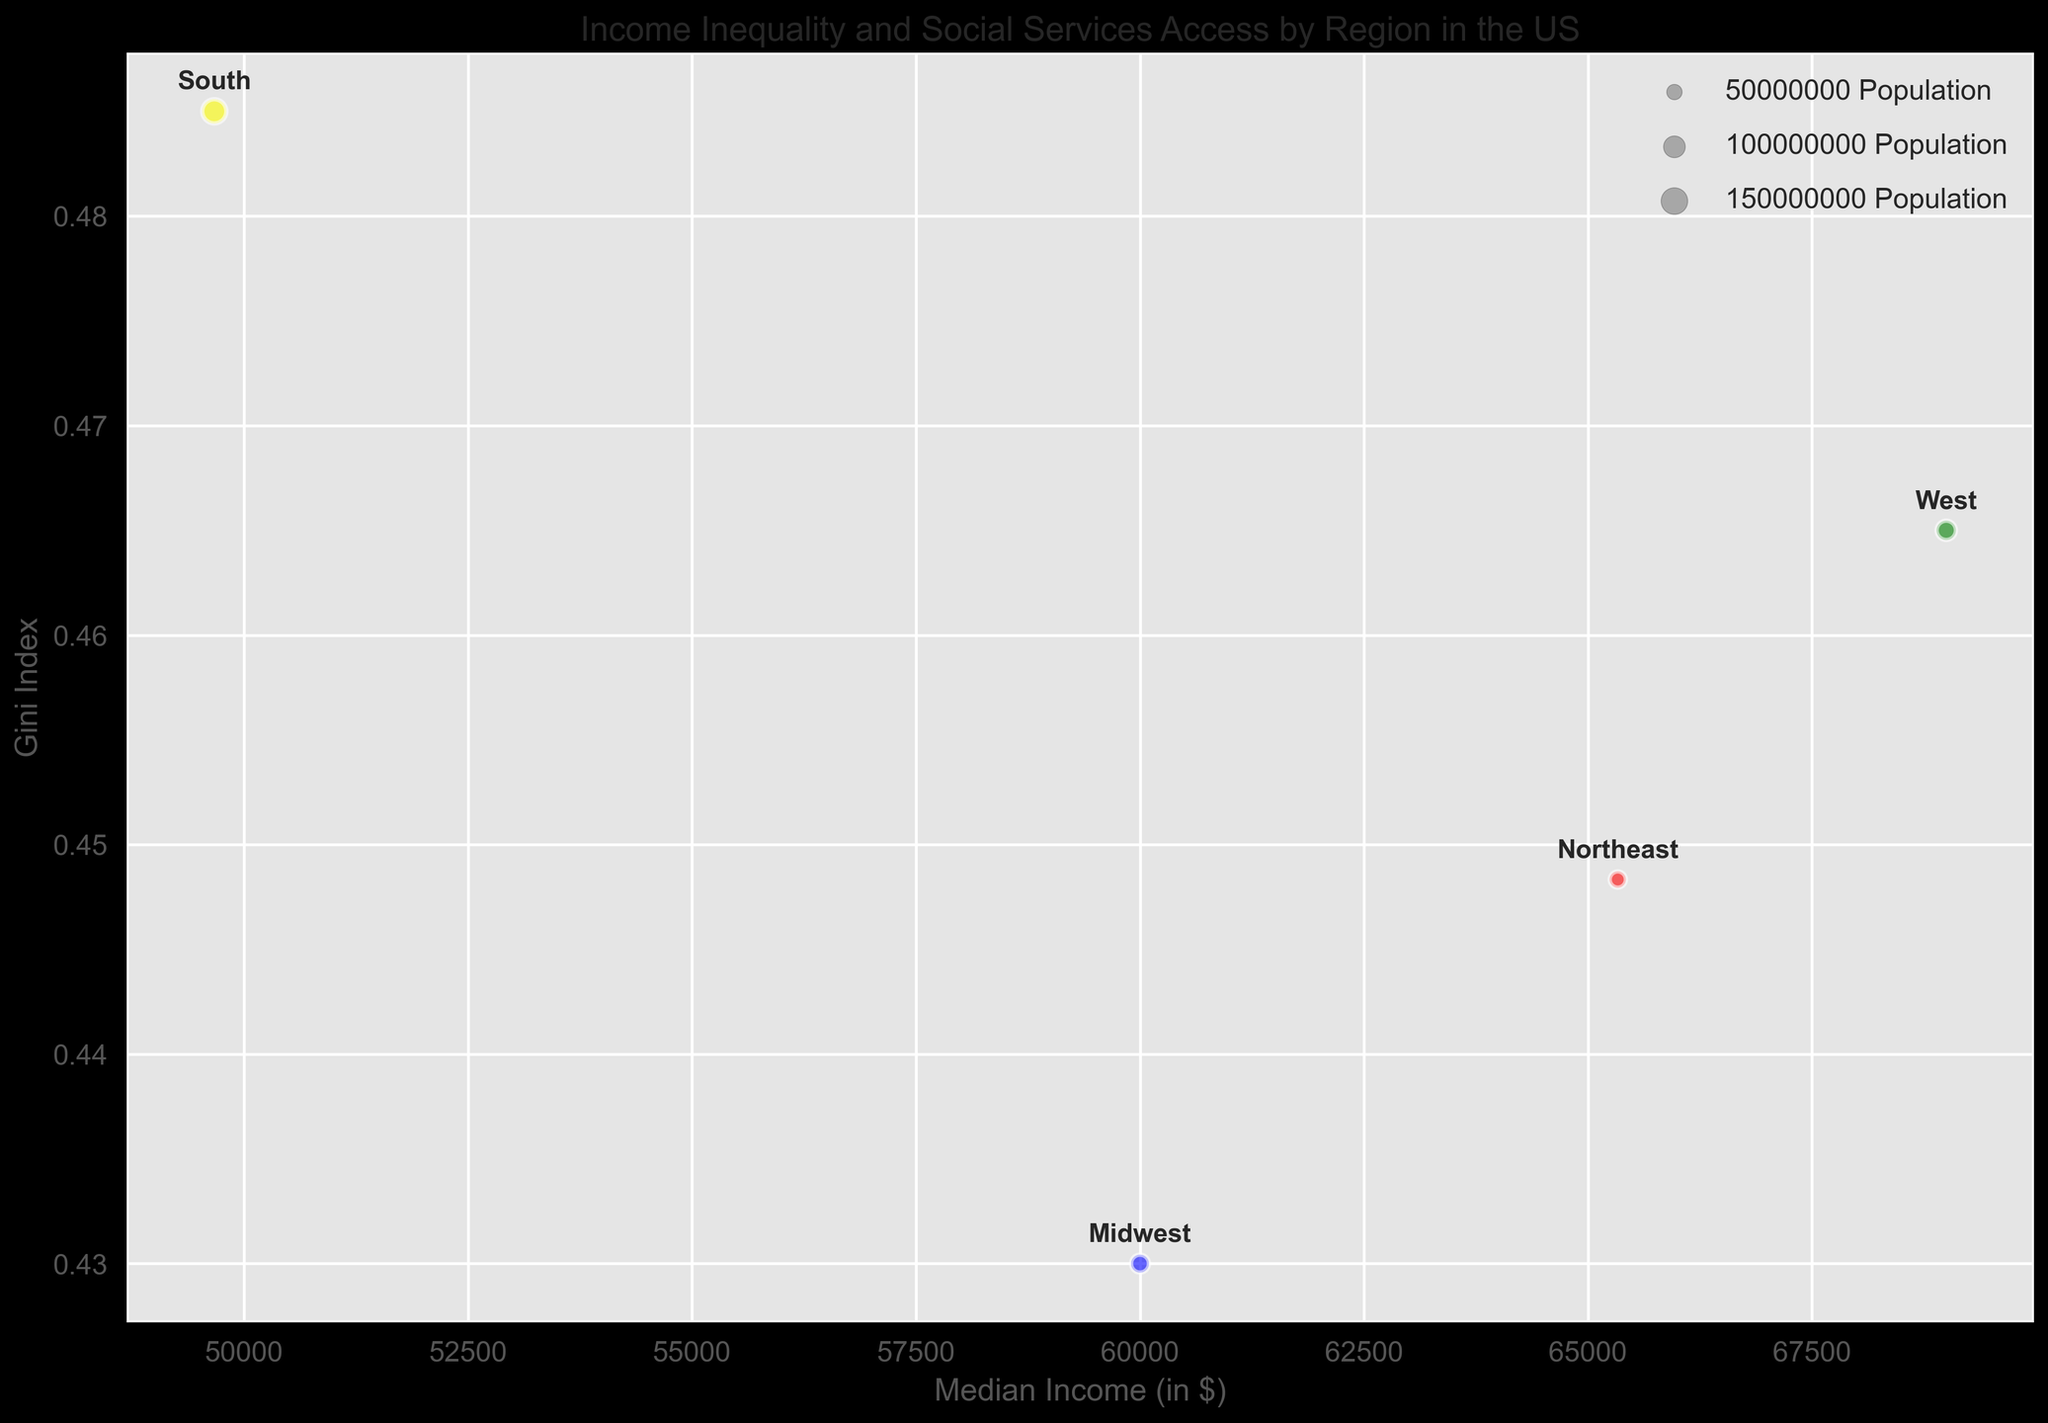Which region has the highest median income? The region with the highest median income can be found by locating the point on the x-axis (Median Income) that is farthest to the right.
Answer: West Which region has the highest Gini Index? The region with the highest Gini Index is identified by finding the point highest on the y-axis (Gini Index).
Answer: South Which region has the largest population? The region with the largest population is indicated by the largest bubble size.
Answer: South How does the Gini Index of the Northeast compare to the Midwest? Compare the vertical positions of the points for Northeast (red) and Midwest (blue) to determine which is higher.
Answer: Northeast has a higher Gini Index Which region has an income range higher than $60,000 and a Gini Index lower than 0.45? The region with an income range higher than $60,000 and a Gini Index lower than 0.45 is found by identifying the point located to the right of $60,000 on the x-axis and below 0.45 on the y-axis.
Answer: Midwest Order the regions by median income from lowest to highest. Locate the points for each region on the x-axis (Median Income) and list them from left to right: South, Midwest, Northeast, West.
Answer: South, Midwest, Northeast, West Which regions have a Gini Index greater than 0.47? Identify all points higher than 0.47 on the y-axis (Gini Index) and note their regions.
Answer: South, West What is the median income of the region with the lowest Gini Index? Identify the region with the lowest Gini Index by finding the lowest point on the y-axis, then refer to the x-value for its median income.
Answer: Midwest Which region has both a high population and a relatively lower Gini Index? A region with a high population will have a large bubble, and a relatively lower Gini Index will be a point lower on the y-axis.
Answer: Midwest Compare the social service spending of the South and Northeast. Social service spending is not directly depicted in the bubble chart; however, if needed, reference supplementary data to compare $2000 for South and $3200 for Northeast.
Answer: Northeast spends more 